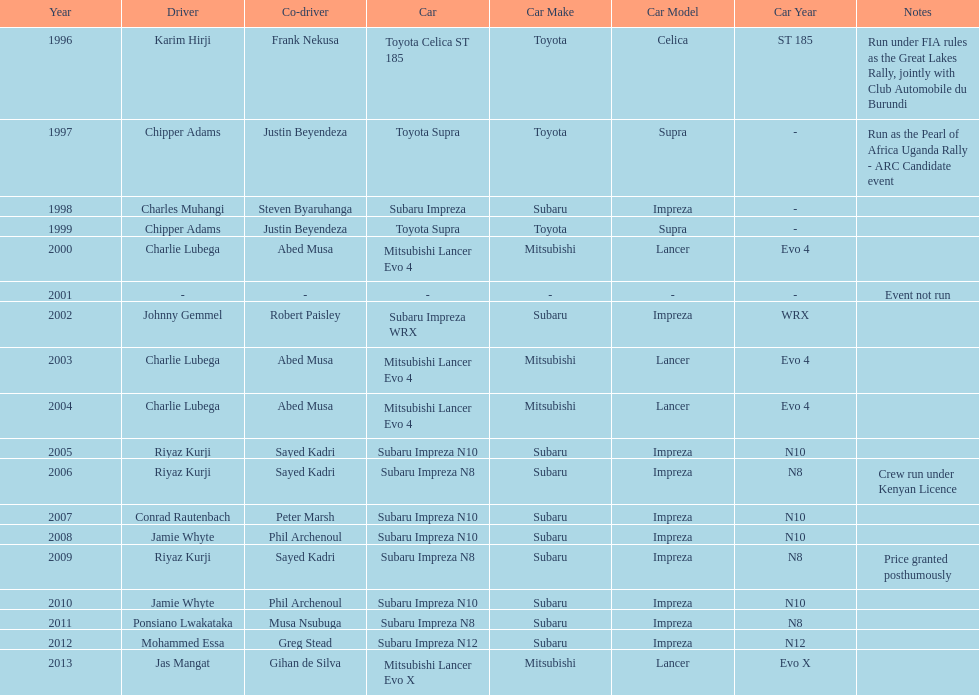Chipper adams and justin beyendeza have how mnay wins? 2. 